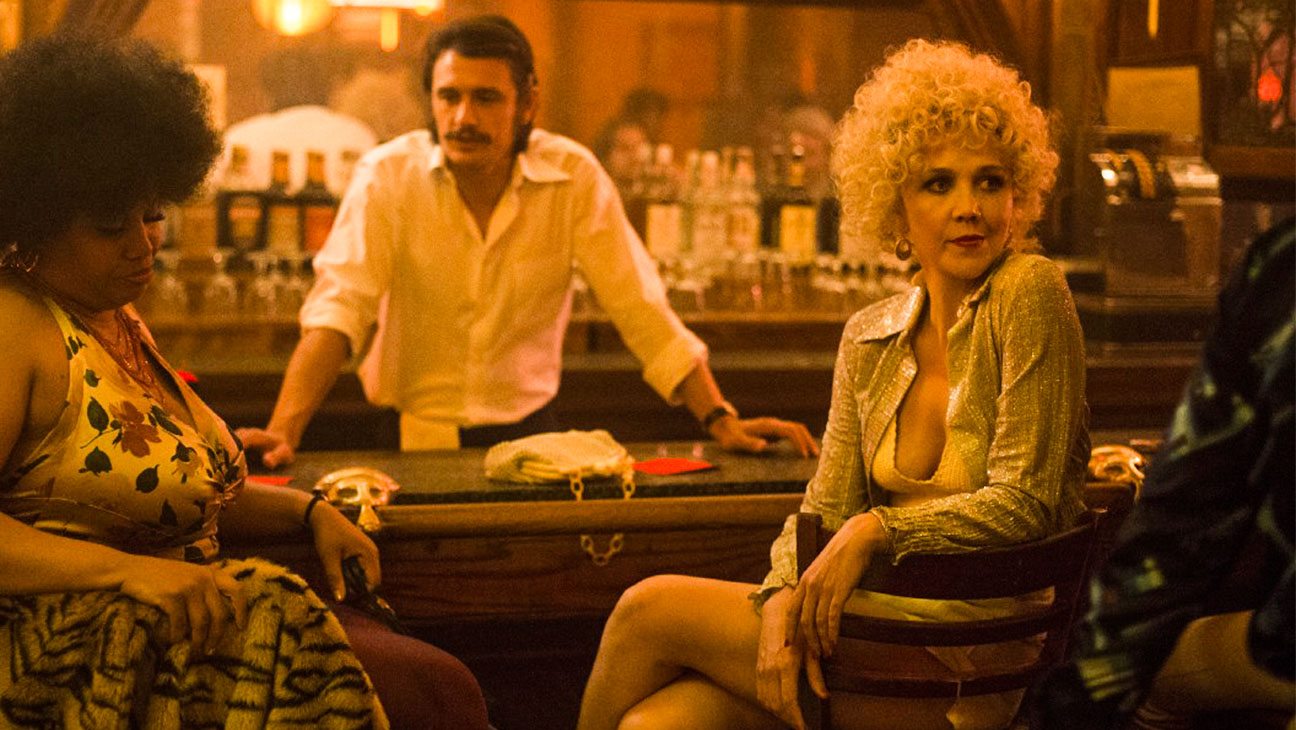What are the key elements in this picture? The image captures a vibrant bar scene featuring a group of individuals. Center stage, a woman in a glittering gold jacket seats leisurely on a barstool, her attitude relaxed yet confident, her gaze direct and slightly challenging. To her left, a woman with afro-textured hair, wearing a floral dress, exudes a sense of ease as she leans casually against the bar. On the opposite side, a man sporting a mustache manifests an attentive demeanor. In the background, a bartender, characterized by his white shirt and mustache, maintains a busy but observant posture. The bar's dim lighting, highlighted by sporadic bright spots from light fixtures, contributes to a warm, intimate atmosphere. Overall, the scene suggests a narrative filled with personal interactions and a layer of sophisticated ambiance. 